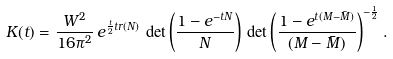<formula> <loc_0><loc_0><loc_500><loc_500>K ( t ) = \frac { W ^ { 2 } } { 1 6 \pi ^ { 2 } } \, e ^ { \frac { t } { 2 } t r ( N ) } \, \det \left ( \frac { { 1 } - e ^ { - t N } } { N } \right ) \, \det \left ( \frac { { 1 } - e ^ { t ( M - \bar { M } ) } } { ( M - \bar { M } ) } \right ) ^ { - \frac { 1 } { 2 } } .</formula> 